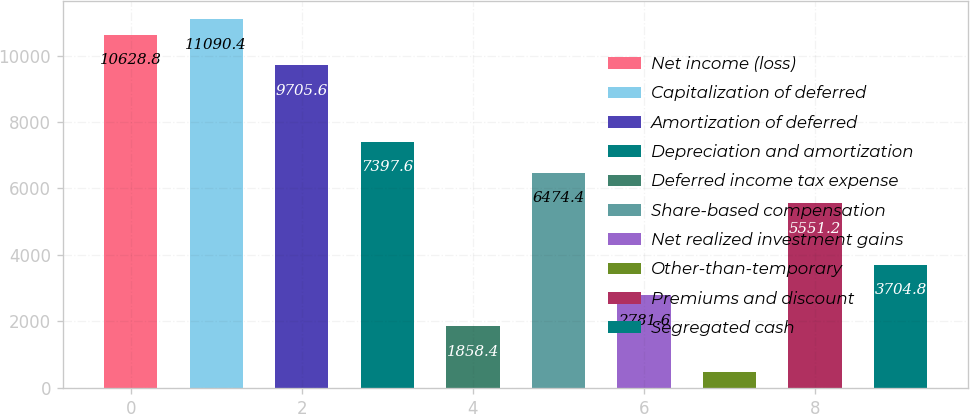Convert chart. <chart><loc_0><loc_0><loc_500><loc_500><bar_chart><fcel>Net income (loss)<fcel>Capitalization of deferred<fcel>Amortization of deferred<fcel>Depreciation and amortization<fcel>Deferred income tax expense<fcel>Share-based compensation<fcel>Net realized investment gains<fcel>Other-than-temporary<fcel>Premiums and discount<fcel>Segregated cash<nl><fcel>10628.8<fcel>11090.4<fcel>9705.6<fcel>7397.6<fcel>1858.4<fcel>6474.4<fcel>2781.6<fcel>473.6<fcel>5551.2<fcel>3704.8<nl></chart> 